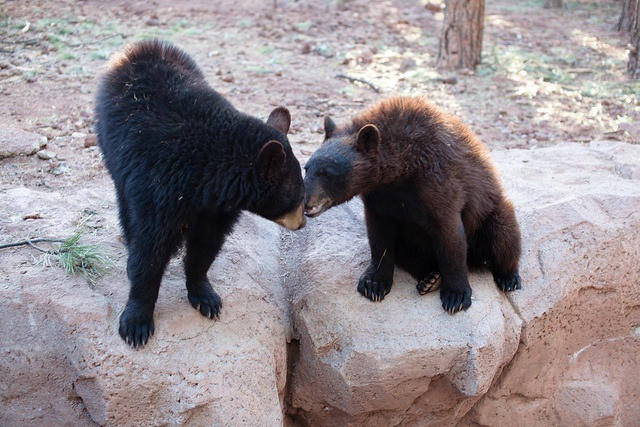Describe the objects in this image and their specific colors. I can see bear in darkgray, black, navy, and gray tones and bear in darkgray, black, and gray tones in this image. 